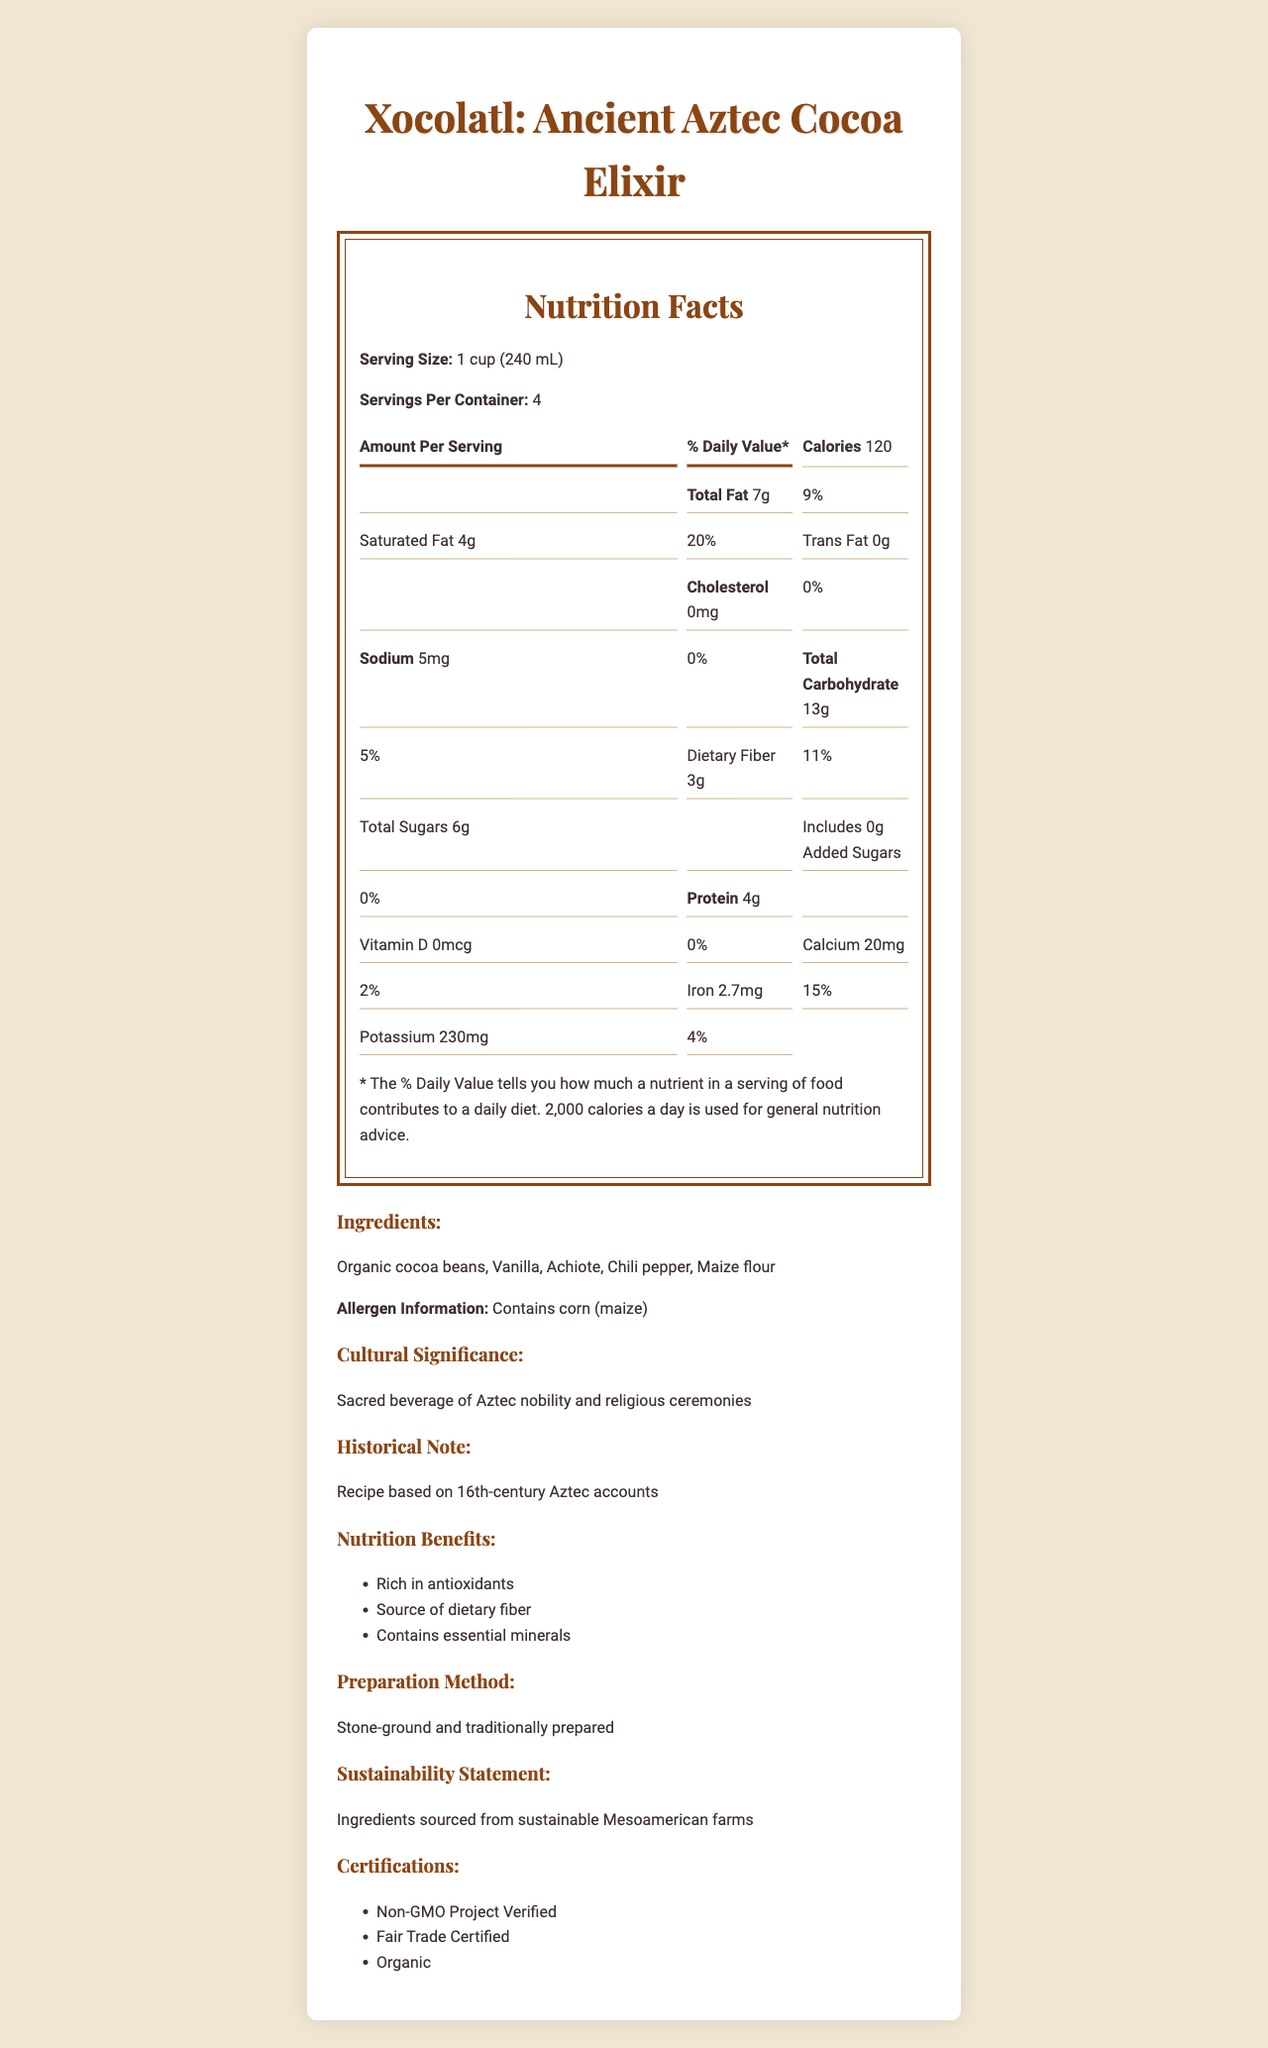What is the serving size of Xocolatl? The serving size is mentioned in the document as "1 cup (240 mL)".
Answer: 1 cup (240 mL) How many calories are in one serving of Xocolatl? The document states that one serving contains 120 calories.
Answer: 120 What is the daily value percentage of saturated fat in one serving? The document shows the saturated fat amount as 4g which is 20% of the daily value.
Answer: 20% List at least three ingredients of Xocolatl. The document lists the ingredients as Organic cocoa beans, Vanilla, Achiote, Chili pepper, and Maize flour.
Answer: Organic cocoa beans, Vanilla, Achiote What percentage of the daily value of dietary fiber does one serving of Xocolatl provide? According to the document, one serving of Xocolatl provides 11% of the daily value of dietary fiber.
Answer: 11% What special certifications does Xocolatl have? A. Non-GMO Project Verified B. Fair Trade Certified C. Organic D. All of the above The document lists all three certifications: Non-GMO Project Verified, Fair Trade Certified, and Organic.
Answer: D. All of the above What is the calcium content in one serving of Xocolatl? A. 2% B. 4% C. 5% D. 10% The document states that the calcium content is 20mg, which is 2% of the daily value.
Answer: A. 2% Is there any added sugar in Xocolatl? The document shows that the added sugars amount is 0g, which is 0% of the daily value.
Answer: No Does the document mention the cultural significance of Xocolatl? The document describes Xocolatl as a sacred beverage of Aztec nobility and religious ceremonies.
Answer: Yes Summarize the main idea of the document. The document is essentially a nutrition facts label for Xocolatl. It includes serving sizes, nutrient amounts, ingredients, and allergen information. Additionally, it highlights the cultural and historical significance, preparation methods, sustainability statements, and certifications of the product.
Answer: The document provides detailed nutritional information, cultural significance, historical notes, ingredients, preparation methods, sustainability practices, and certifications for Xocolatl, an ancient Aztec cocoa elixir. Which civilization is the geometric pattern on the document inspired by? The document mentions that the geometric pattern is inspired by Aztec Sun Stone motifs.
Answer: Aztec Is the protein content of Xocolatl higher or lower than the total sugars content? The document lists the protein content as 4g and the total sugars content as 6g.
Answer: Lower What kind of farms are the ingredients sourced from? The document specifies that the ingredients are sourced from sustainable Mesoamerican farms.
Answer: Sustainable Mesoamerican farms What is the sustainability statement of Xocolatl? The document explicitly states this as the sustainability statement.
Answer: Ingredients sourced from sustainable Mesoamerican farms How many servings are there per container? The document mentions that there are 4 servings per container.
Answer: 4 What is the level of Vitamin D in Xocolatl? The document states that the amount of Vitamin D in Xocolatl is 0mcg, which is 0% of the daily value.
Answer: 0mcg What is the preparation method for Xocolatl? The document notes that Xocolatl is stone-ground and traditionally prepared.
Answer: Stone-ground and traditionally prepared What is the historical note mentioned in the document about Xocolatl? The document states that the recipe for Xocolatl is based on 16th-century Aztec accounts.
Answer: Recipe based on 16th-century Aztec accounts What allergens are present in Xocolatl? The allergen information section indicates that it contains corn (maize).
Answer: Contains corn (maize) Which specific minerals are listed in the nutrition benefits of Xocolatl? The document states that it contains essential minerals but does not specify which ones.
Answer: Cannot be determined 